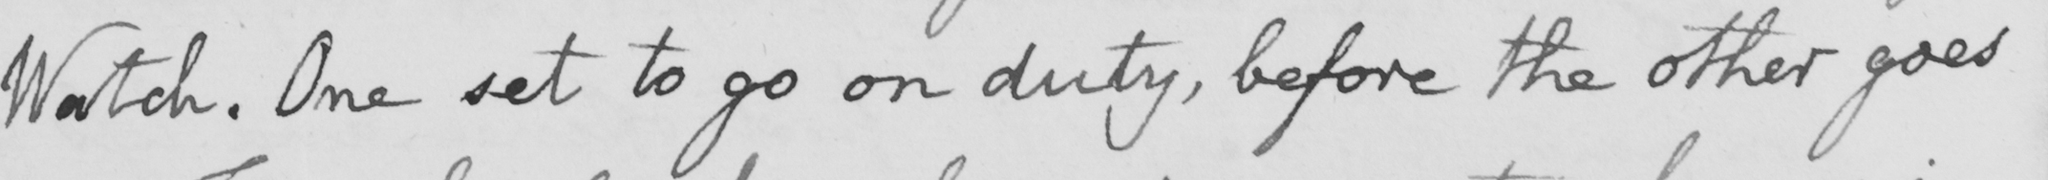What does this handwritten line say? Watch . One set to go on duty , before the other goes 